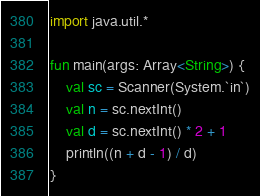<code> <loc_0><loc_0><loc_500><loc_500><_Kotlin_>import java.util.*

fun main(args: Array<String>) {
    val sc = Scanner(System.`in`)
    val n = sc.nextInt()
    val d = sc.nextInt() * 2 + 1
    println((n + d - 1) / d)
}</code> 